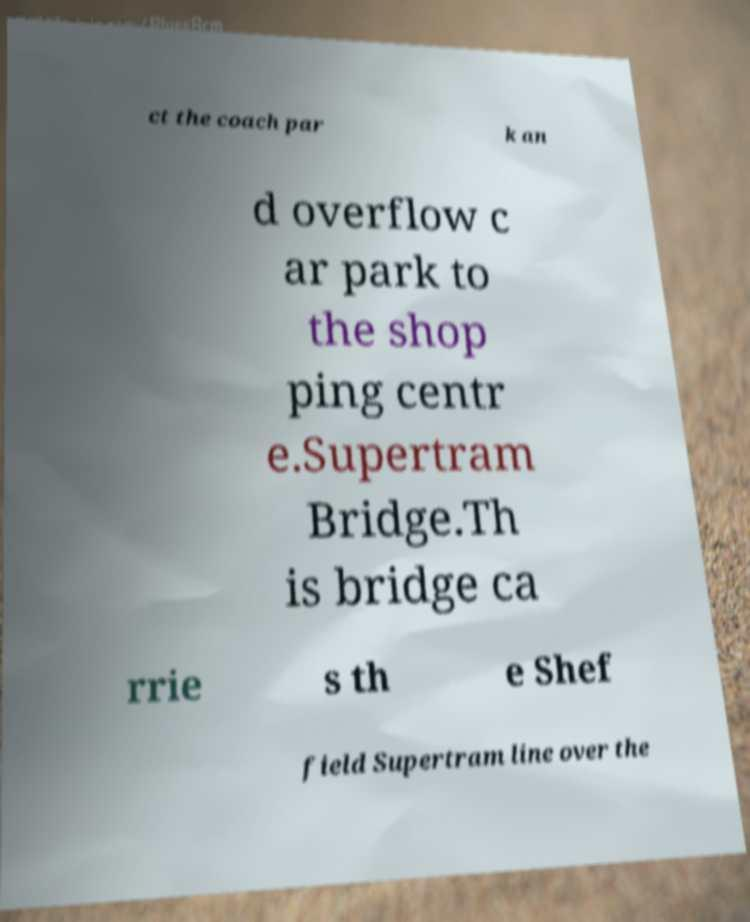Please read and relay the text visible in this image. What does it say? ct the coach par k an d overflow c ar park to the shop ping centr e.Supertram Bridge.Th is bridge ca rrie s th e Shef field Supertram line over the 